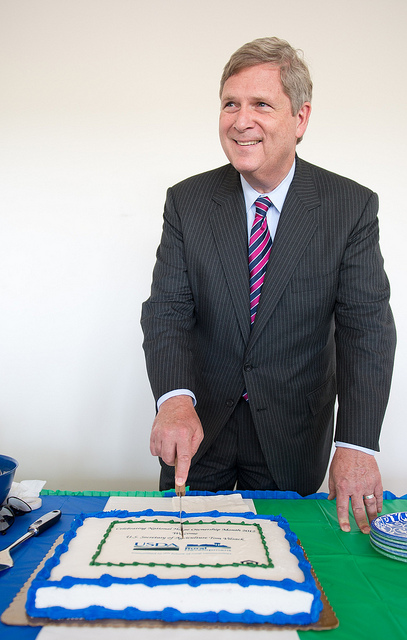Identify and read out the text in this image. USDA 